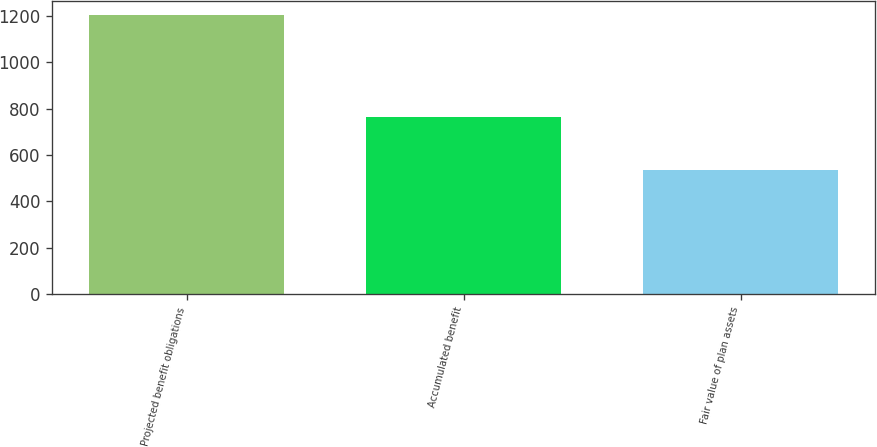<chart> <loc_0><loc_0><loc_500><loc_500><bar_chart><fcel>Projected benefit obligations<fcel>Accumulated benefit<fcel>Fair value of plan assets<nl><fcel>1203<fcel>763<fcel>535<nl></chart> 